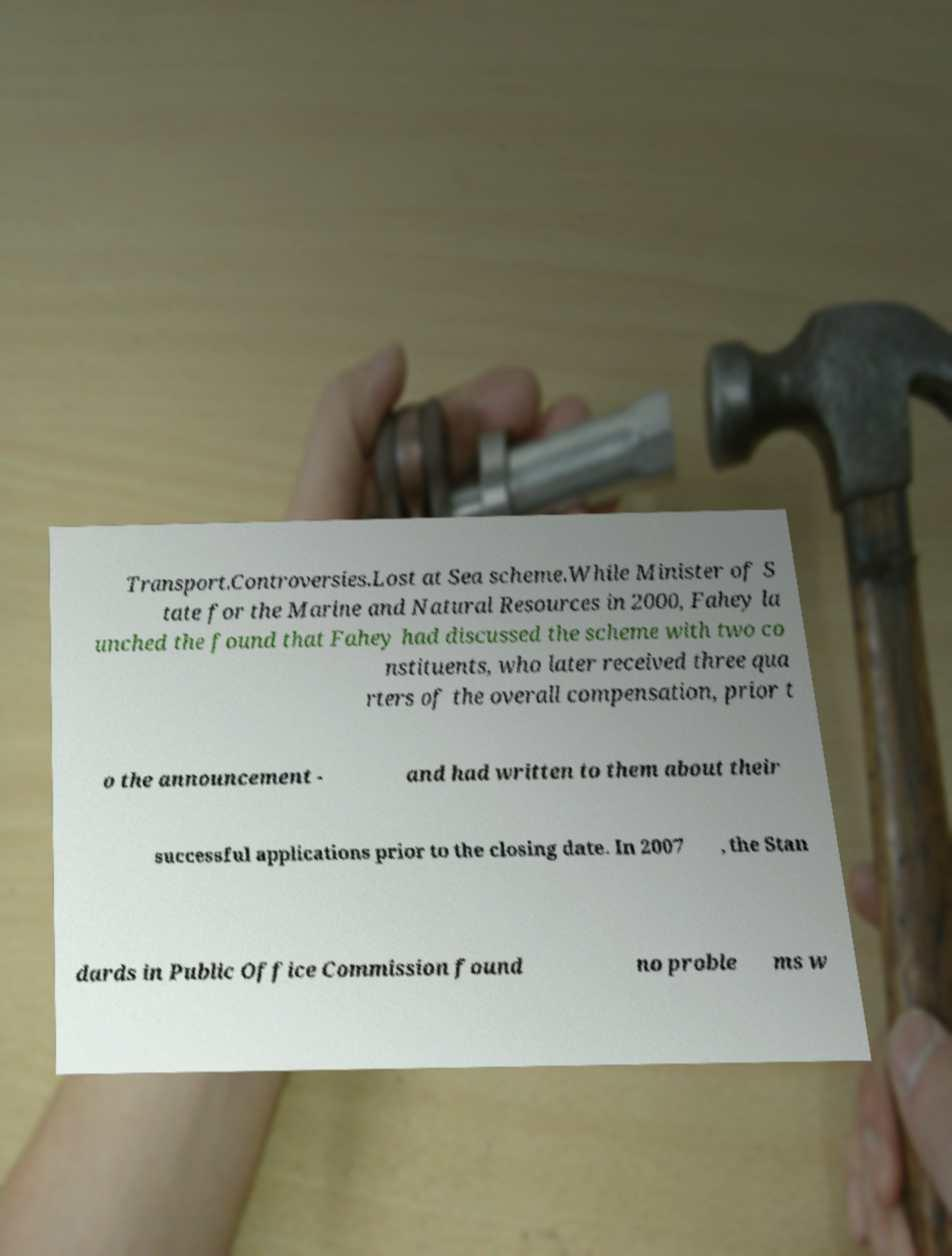Please identify and transcribe the text found in this image. Transport.Controversies.Lost at Sea scheme.While Minister of S tate for the Marine and Natural Resources in 2000, Fahey la unched the found that Fahey had discussed the scheme with two co nstituents, who later received three qua rters of the overall compensation, prior t o the announcement - and had written to them about their successful applications prior to the closing date. In 2007 , the Stan dards in Public Office Commission found no proble ms w 